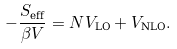Convert formula to latex. <formula><loc_0><loc_0><loc_500><loc_500>- \frac { S _ { \text {eff} } } { \beta V } = N V _ { \text {LO} } + V _ { \text {NLO} } .</formula> 